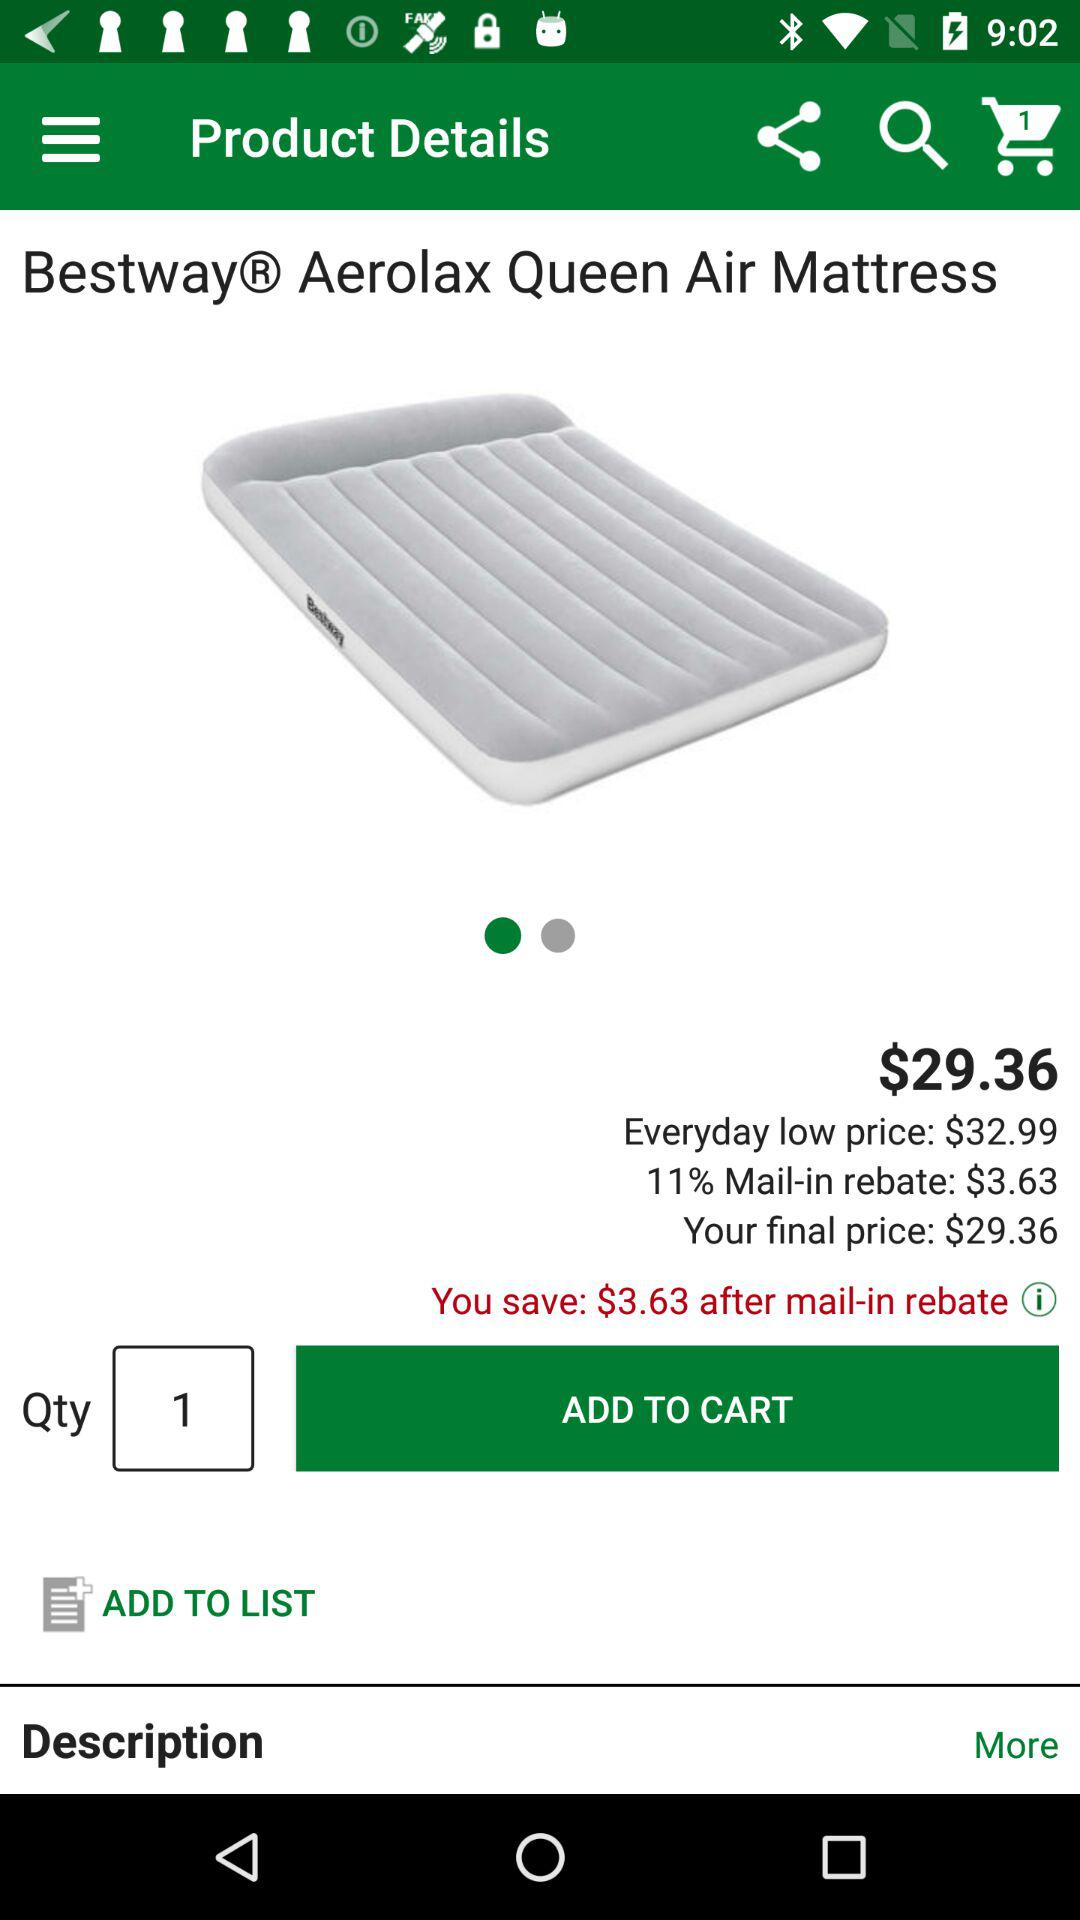What is the currency of the price? The currency of the price is dollars. 